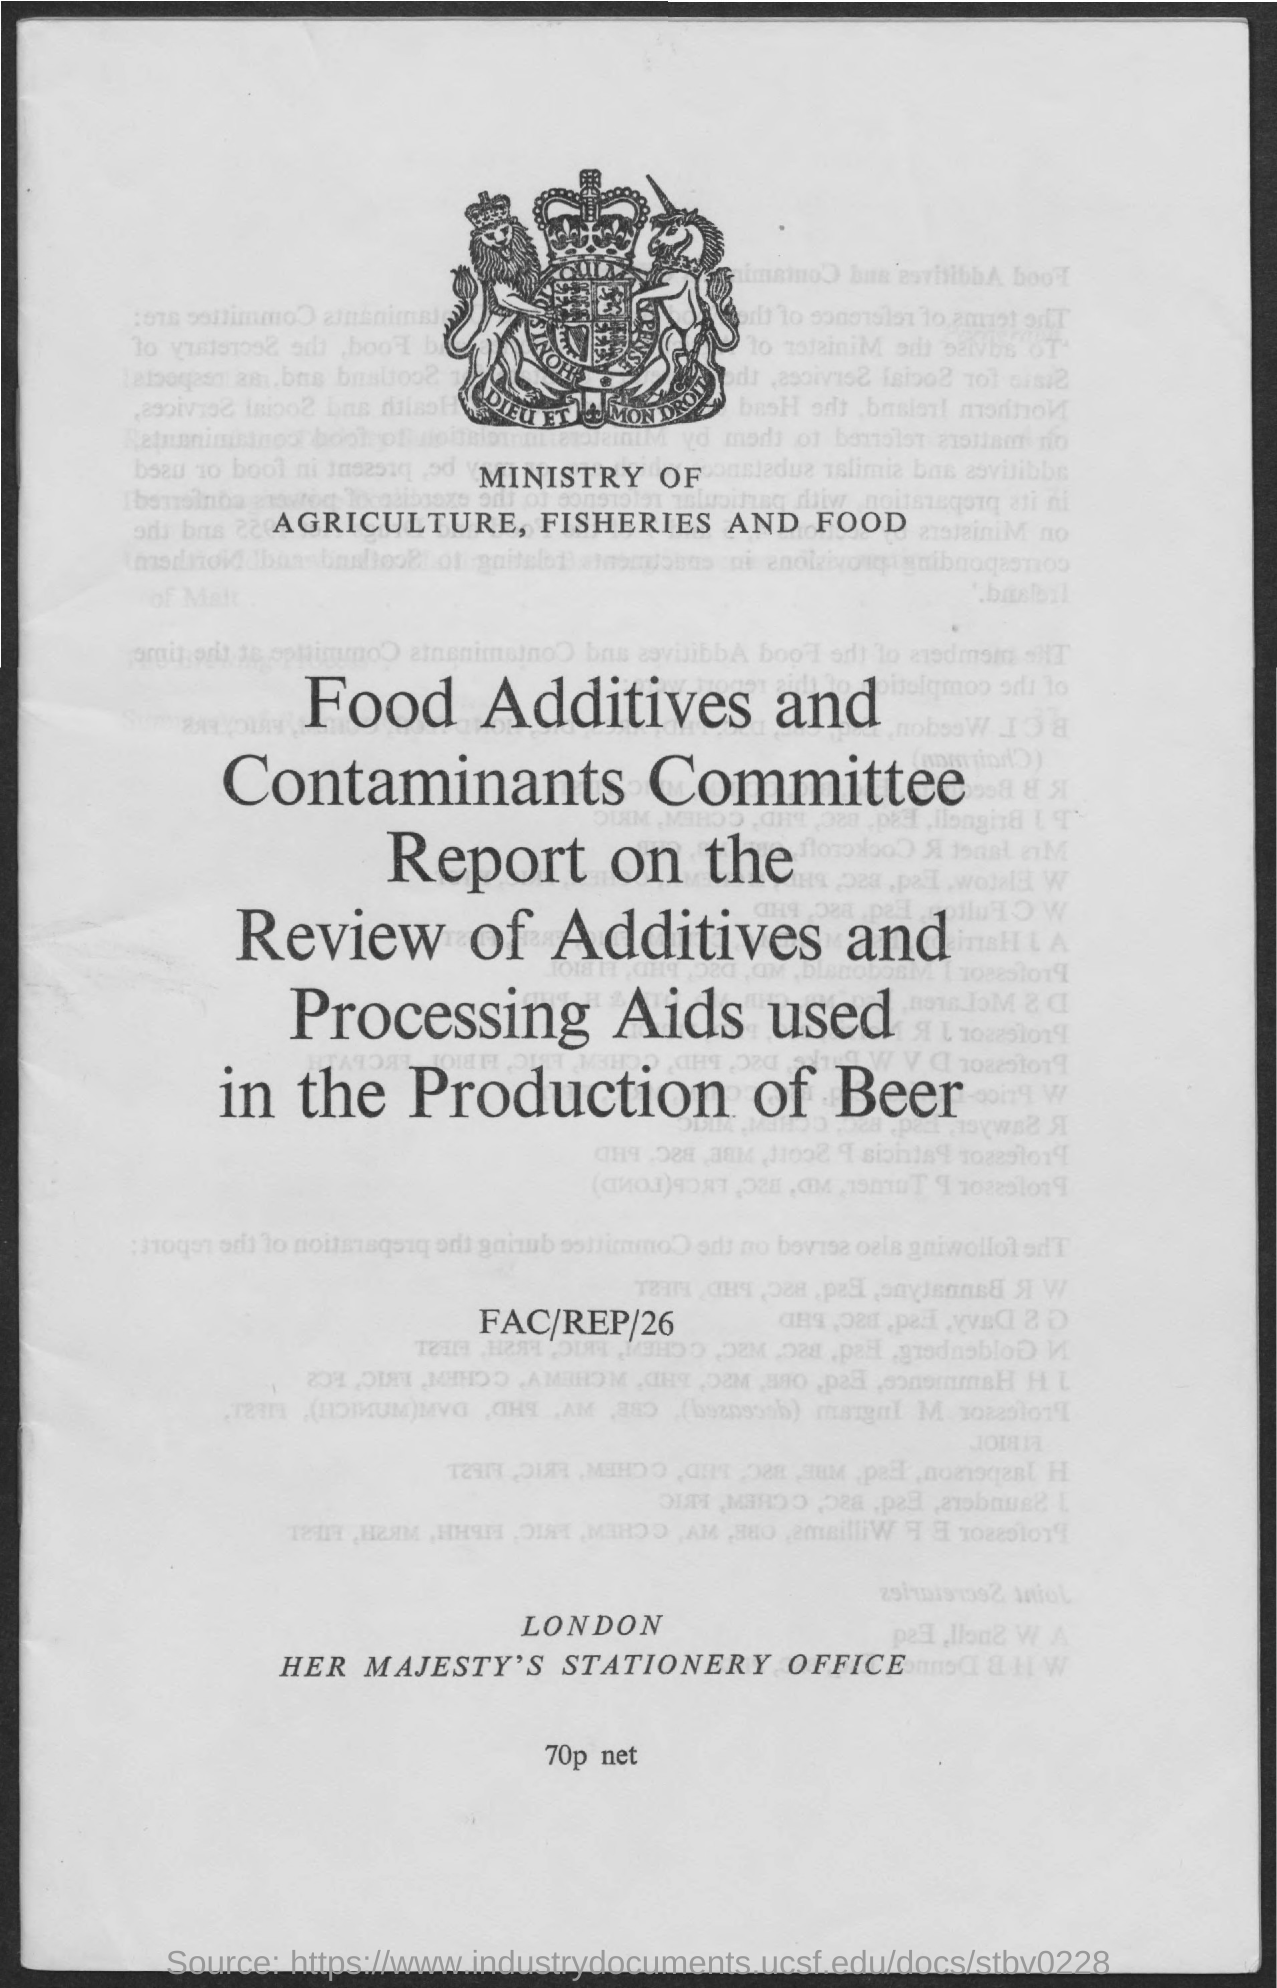Give some essential details in this illustration. The Ministry of Agriculture, Fisheries and Food is located below the logo. 